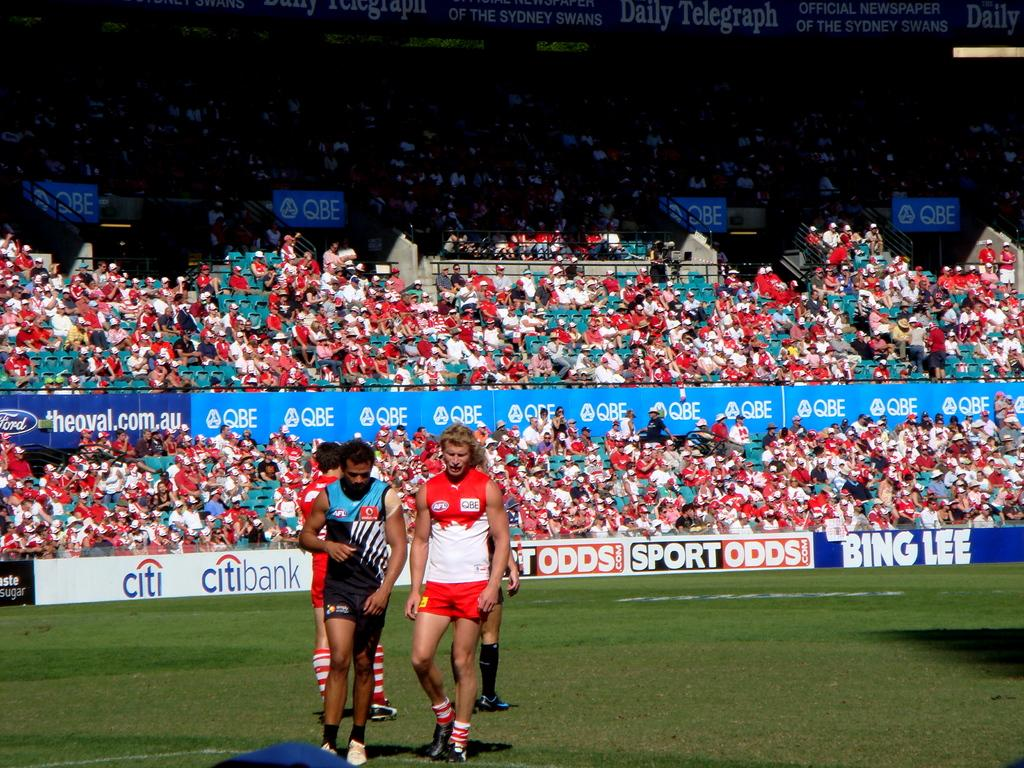What is the location of the men in the image? The men are in the foreground area of the image. What type of terrain is visible in the image? The men are on a grassland. Who else is present in the image besides the men? There are people sitting as an audience in the image. What can be seen on the boundaries in the background area? There are posters on the boundaries in the background area. What type of vest is the bee wearing in the image? There are no bees or vests present in the image. 